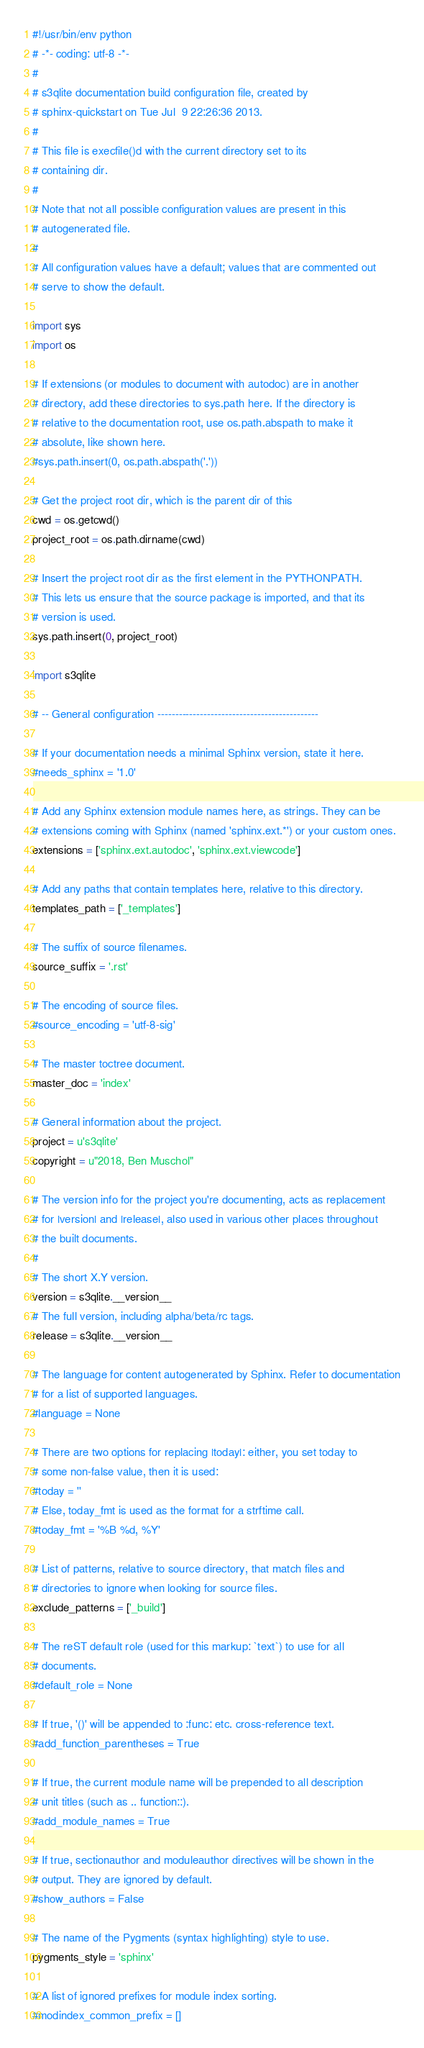Convert code to text. <code><loc_0><loc_0><loc_500><loc_500><_Python_>#!/usr/bin/env python
# -*- coding: utf-8 -*-
#
# s3qlite documentation build configuration file, created by
# sphinx-quickstart on Tue Jul  9 22:26:36 2013.
#
# This file is execfile()d with the current directory set to its
# containing dir.
#
# Note that not all possible configuration values are present in this
# autogenerated file.
#
# All configuration values have a default; values that are commented out
# serve to show the default.

import sys
import os

# If extensions (or modules to document with autodoc) are in another
# directory, add these directories to sys.path here. If the directory is
# relative to the documentation root, use os.path.abspath to make it
# absolute, like shown here.
#sys.path.insert(0, os.path.abspath('.'))

# Get the project root dir, which is the parent dir of this
cwd = os.getcwd()
project_root = os.path.dirname(cwd)

# Insert the project root dir as the first element in the PYTHONPATH.
# This lets us ensure that the source package is imported, and that its
# version is used.
sys.path.insert(0, project_root)

import s3qlite

# -- General configuration ---------------------------------------------

# If your documentation needs a minimal Sphinx version, state it here.
#needs_sphinx = '1.0'

# Add any Sphinx extension module names here, as strings. They can be
# extensions coming with Sphinx (named 'sphinx.ext.*') or your custom ones.
extensions = ['sphinx.ext.autodoc', 'sphinx.ext.viewcode']

# Add any paths that contain templates here, relative to this directory.
templates_path = ['_templates']

# The suffix of source filenames.
source_suffix = '.rst'

# The encoding of source files.
#source_encoding = 'utf-8-sig'

# The master toctree document.
master_doc = 'index'

# General information about the project.
project = u's3qlite'
copyright = u"2018, Ben Muschol"

# The version info for the project you're documenting, acts as replacement
# for |version| and |release|, also used in various other places throughout
# the built documents.
#
# The short X.Y version.
version = s3qlite.__version__
# The full version, including alpha/beta/rc tags.
release = s3qlite.__version__

# The language for content autogenerated by Sphinx. Refer to documentation
# for a list of supported languages.
#language = None

# There are two options for replacing |today|: either, you set today to
# some non-false value, then it is used:
#today = ''
# Else, today_fmt is used as the format for a strftime call.
#today_fmt = '%B %d, %Y'

# List of patterns, relative to source directory, that match files and
# directories to ignore when looking for source files.
exclude_patterns = ['_build']

# The reST default role (used for this markup: `text`) to use for all
# documents.
#default_role = None

# If true, '()' will be appended to :func: etc. cross-reference text.
#add_function_parentheses = True

# If true, the current module name will be prepended to all description
# unit titles (such as .. function::).
#add_module_names = True

# If true, sectionauthor and moduleauthor directives will be shown in the
# output. They are ignored by default.
#show_authors = False

# The name of the Pygments (syntax highlighting) style to use.
pygments_style = 'sphinx'

# A list of ignored prefixes for module index sorting.
#modindex_common_prefix = []
</code> 